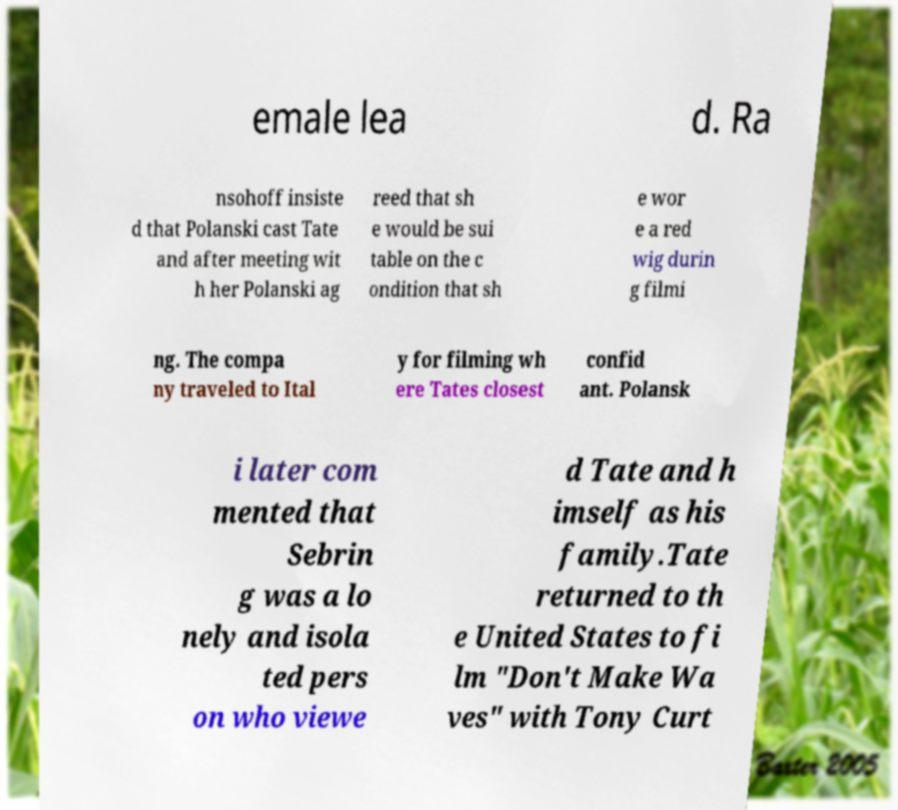For documentation purposes, I need the text within this image transcribed. Could you provide that? emale lea d. Ra nsohoff insiste d that Polanski cast Tate and after meeting wit h her Polanski ag reed that sh e would be sui table on the c ondition that sh e wor e a red wig durin g filmi ng. The compa ny traveled to Ital y for filming wh ere Tates closest confid ant. Polansk i later com mented that Sebrin g was a lo nely and isola ted pers on who viewe d Tate and h imself as his family.Tate returned to th e United States to fi lm "Don't Make Wa ves" with Tony Curt 